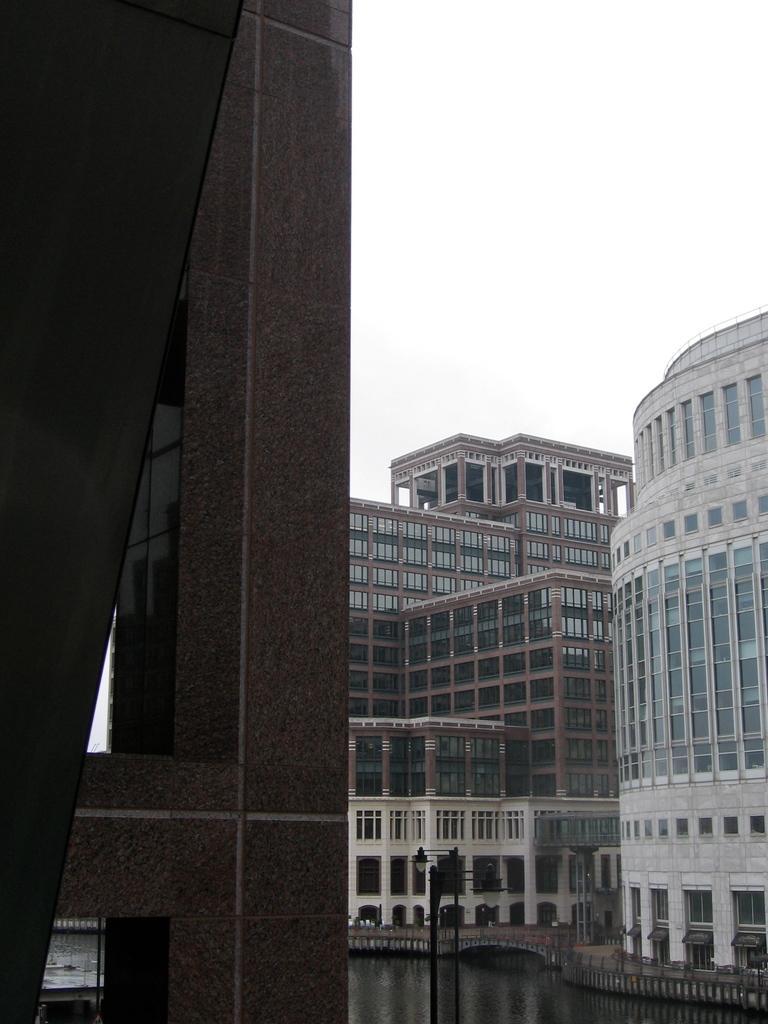Describe this image in one or two sentences. In this picture we can see the buildings. On the left side of the image, there is an architecture. At the bottom of the image, there are poles and water. At the top of the image, there is the sky. 